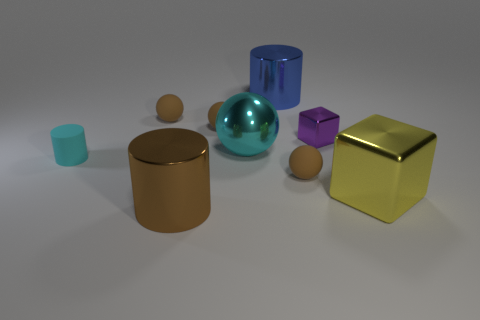Subtract all shiny spheres. How many spheres are left? 3 Subtract all green cylinders. How many brown spheres are left? 3 Add 1 cyan balls. How many objects exist? 10 Subtract 1 balls. How many balls are left? 3 Subtract all blocks. How many objects are left? 7 Subtract all purple cubes. How many cubes are left? 1 Subtract 0 yellow balls. How many objects are left? 9 Subtract all gray spheres. Subtract all brown cubes. How many spheres are left? 4 Subtract all big metal things. Subtract all big balls. How many objects are left? 4 Add 3 large cyan balls. How many large cyan balls are left? 4 